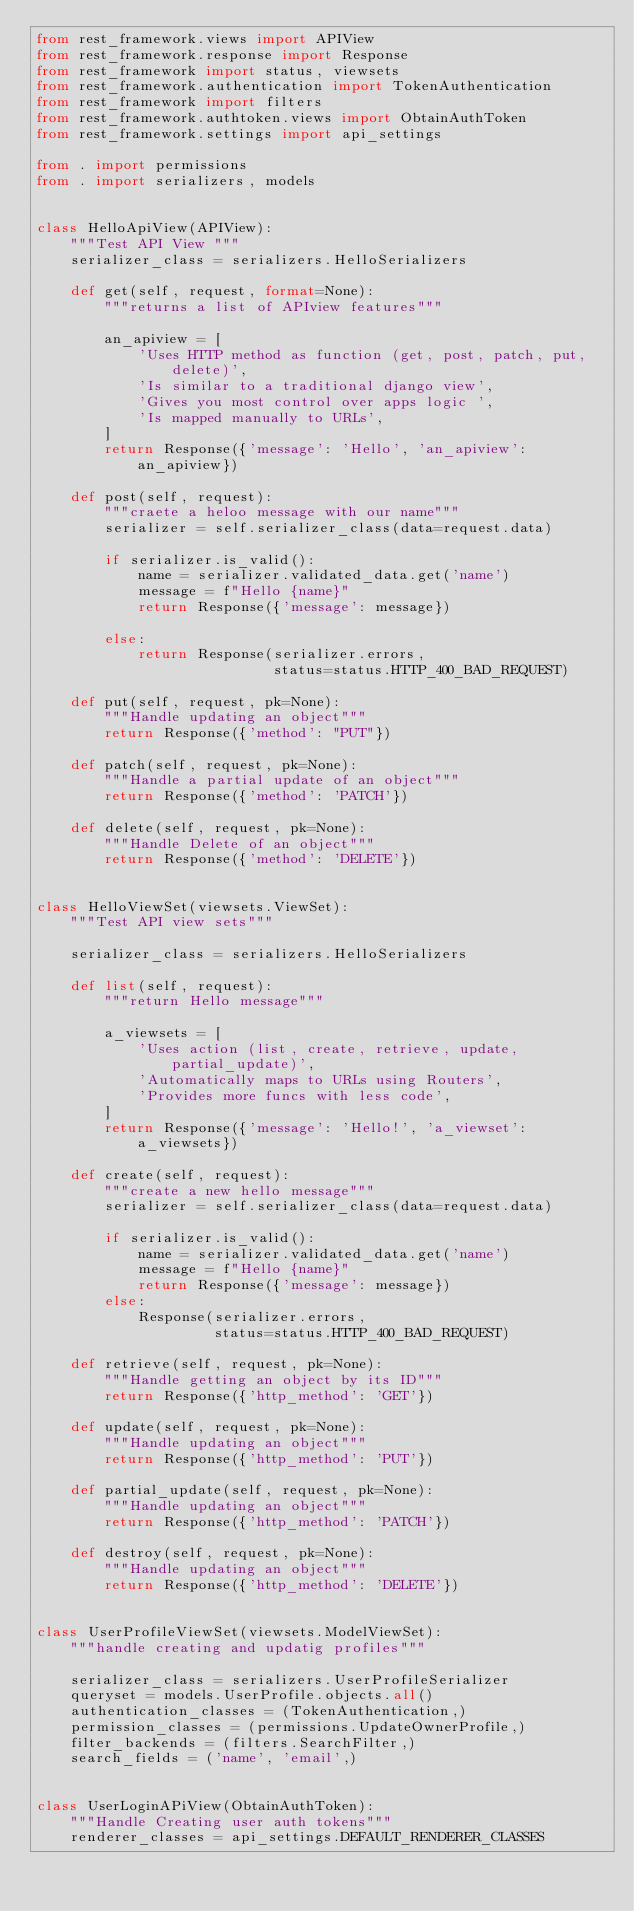Convert code to text. <code><loc_0><loc_0><loc_500><loc_500><_Python_>from rest_framework.views import APIView
from rest_framework.response import Response
from rest_framework import status, viewsets
from rest_framework.authentication import TokenAuthentication
from rest_framework import filters
from rest_framework.authtoken.views import ObtainAuthToken
from rest_framework.settings import api_settings

from . import permissions
from . import serializers, models


class HelloApiView(APIView):
    """Test API View """
    serializer_class = serializers.HelloSerializers

    def get(self, request, format=None):
        """returns a list of APIview features"""

        an_apiview = [
            'Uses HTTP method as function (get, post, patch, put, delete)',
            'Is similar to a traditional django view',
            'Gives you most control over apps logic ',
            'Is mapped manually to URLs',
        ]
        return Response({'message': 'Hello', 'an_apiview': an_apiview})

    def post(self, request):
        """craete a heloo message with our name"""
        serializer = self.serializer_class(data=request.data)

        if serializer.is_valid():
            name = serializer.validated_data.get('name')
            message = f"Hello {name}"
            return Response({'message': message})

        else:
            return Response(serializer.errors,
                            status=status.HTTP_400_BAD_REQUEST)

    def put(self, request, pk=None):
        """Handle updating an object"""
        return Response({'method': "PUT"})

    def patch(self, request, pk=None):
        """Handle a partial update of an object"""
        return Response({'method': 'PATCH'})

    def delete(self, request, pk=None):
        """Handle Delete of an object"""
        return Response({'method': 'DELETE'})


class HelloViewSet(viewsets.ViewSet):
    """Test API view sets"""

    serializer_class = serializers.HelloSerializers

    def list(self, request):
        """return Hello message"""

        a_viewsets = [
            'Uses action (list, create, retrieve, update, partial_update)',
            'Automatically maps to URLs using Routers',
            'Provides more funcs with less code',
        ]
        return Response({'message': 'Hello!', 'a_viewset': a_viewsets})

    def create(self, request):
        """create a new hello message"""
        serializer = self.serializer_class(data=request.data)

        if serializer.is_valid():
            name = serializer.validated_data.get('name')
            message = f"Hello {name}"
            return Response({'message': message})
        else:
            Response(serializer.errors,
                     status=status.HTTP_400_BAD_REQUEST)

    def retrieve(self, request, pk=None):
        """Handle getting an object by its ID"""
        return Response({'http_method': 'GET'})

    def update(self, request, pk=None):
        """Handle updating an object"""
        return Response({'http_method': 'PUT'})

    def partial_update(self, request, pk=None):
        """Handle updating an object"""
        return Response({'http_method': 'PATCH'})

    def destroy(self, request, pk=None):
        """Handle updating an object"""
        return Response({'http_method': 'DELETE'})


class UserProfileViewSet(viewsets.ModelViewSet):
    """handle creating and updatig profiles"""

    serializer_class = serializers.UserProfileSerializer
    queryset = models.UserProfile.objects.all()
    authentication_classes = (TokenAuthentication,)
    permission_classes = (permissions.UpdateOwnerProfile,)
    filter_backends = (filters.SearchFilter,)
    search_fields = ('name', 'email',)


class UserLoginAPiView(ObtainAuthToken):
    """Handle Creating user auth tokens"""
    renderer_classes = api_settings.DEFAULT_RENDERER_CLASSES
</code> 